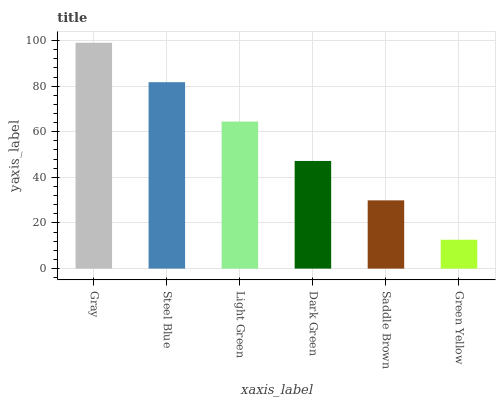Is Green Yellow the minimum?
Answer yes or no. Yes. Is Gray the maximum?
Answer yes or no. Yes. Is Steel Blue the minimum?
Answer yes or no. No. Is Steel Blue the maximum?
Answer yes or no. No. Is Gray greater than Steel Blue?
Answer yes or no. Yes. Is Steel Blue less than Gray?
Answer yes or no. Yes. Is Steel Blue greater than Gray?
Answer yes or no. No. Is Gray less than Steel Blue?
Answer yes or no. No. Is Light Green the high median?
Answer yes or no. Yes. Is Dark Green the low median?
Answer yes or no. Yes. Is Steel Blue the high median?
Answer yes or no. No. Is Steel Blue the low median?
Answer yes or no. No. 